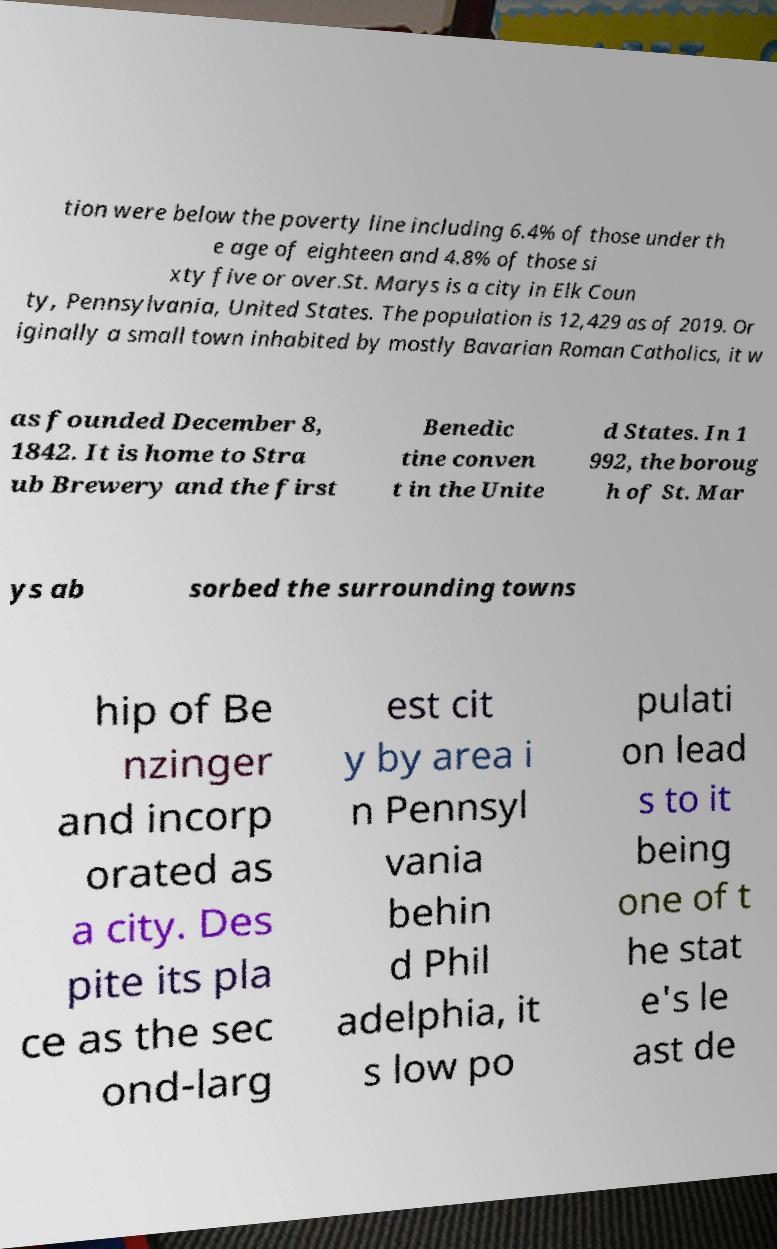Please read and relay the text visible in this image. What does it say? tion were below the poverty line including 6.4% of those under th e age of eighteen and 4.8% of those si xty five or over.St. Marys is a city in Elk Coun ty, Pennsylvania, United States. The population is 12,429 as of 2019. Or iginally a small town inhabited by mostly Bavarian Roman Catholics, it w as founded December 8, 1842. It is home to Stra ub Brewery and the first Benedic tine conven t in the Unite d States. In 1 992, the boroug h of St. Mar ys ab sorbed the surrounding towns hip of Be nzinger and incorp orated as a city. Des pite its pla ce as the sec ond-larg est cit y by area i n Pennsyl vania behin d Phil adelphia, it s low po pulati on lead s to it being one of t he stat e's le ast de 